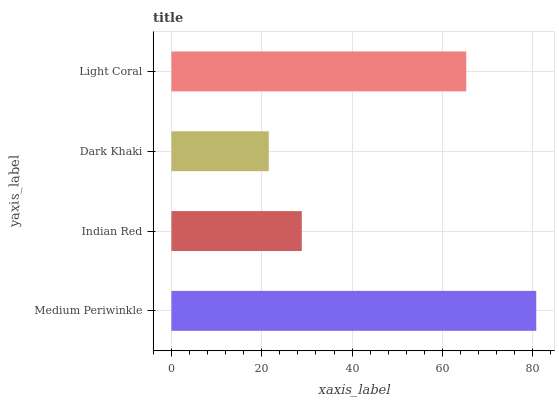Is Dark Khaki the minimum?
Answer yes or no. Yes. Is Medium Periwinkle the maximum?
Answer yes or no. Yes. Is Indian Red the minimum?
Answer yes or no. No. Is Indian Red the maximum?
Answer yes or no. No. Is Medium Periwinkle greater than Indian Red?
Answer yes or no. Yes. Is Indian Red less than Medium Periwinkle?
Answer yes or no. Yes. Is Indian Red greater than Medium Periwinkle?
Answer yes or no. No. Is Medium Periwinkle less than Indian Red?
Answer yes or no. No. Is Light Coral the high median?
Answer yes or no. Yes. Is Indian Red the low median?
Answer yes or no. Yes. Is Indian Red the high median?
Answer yes or no. No. Is Medium Periwinkle the low median?
Answer yes or no. No. 